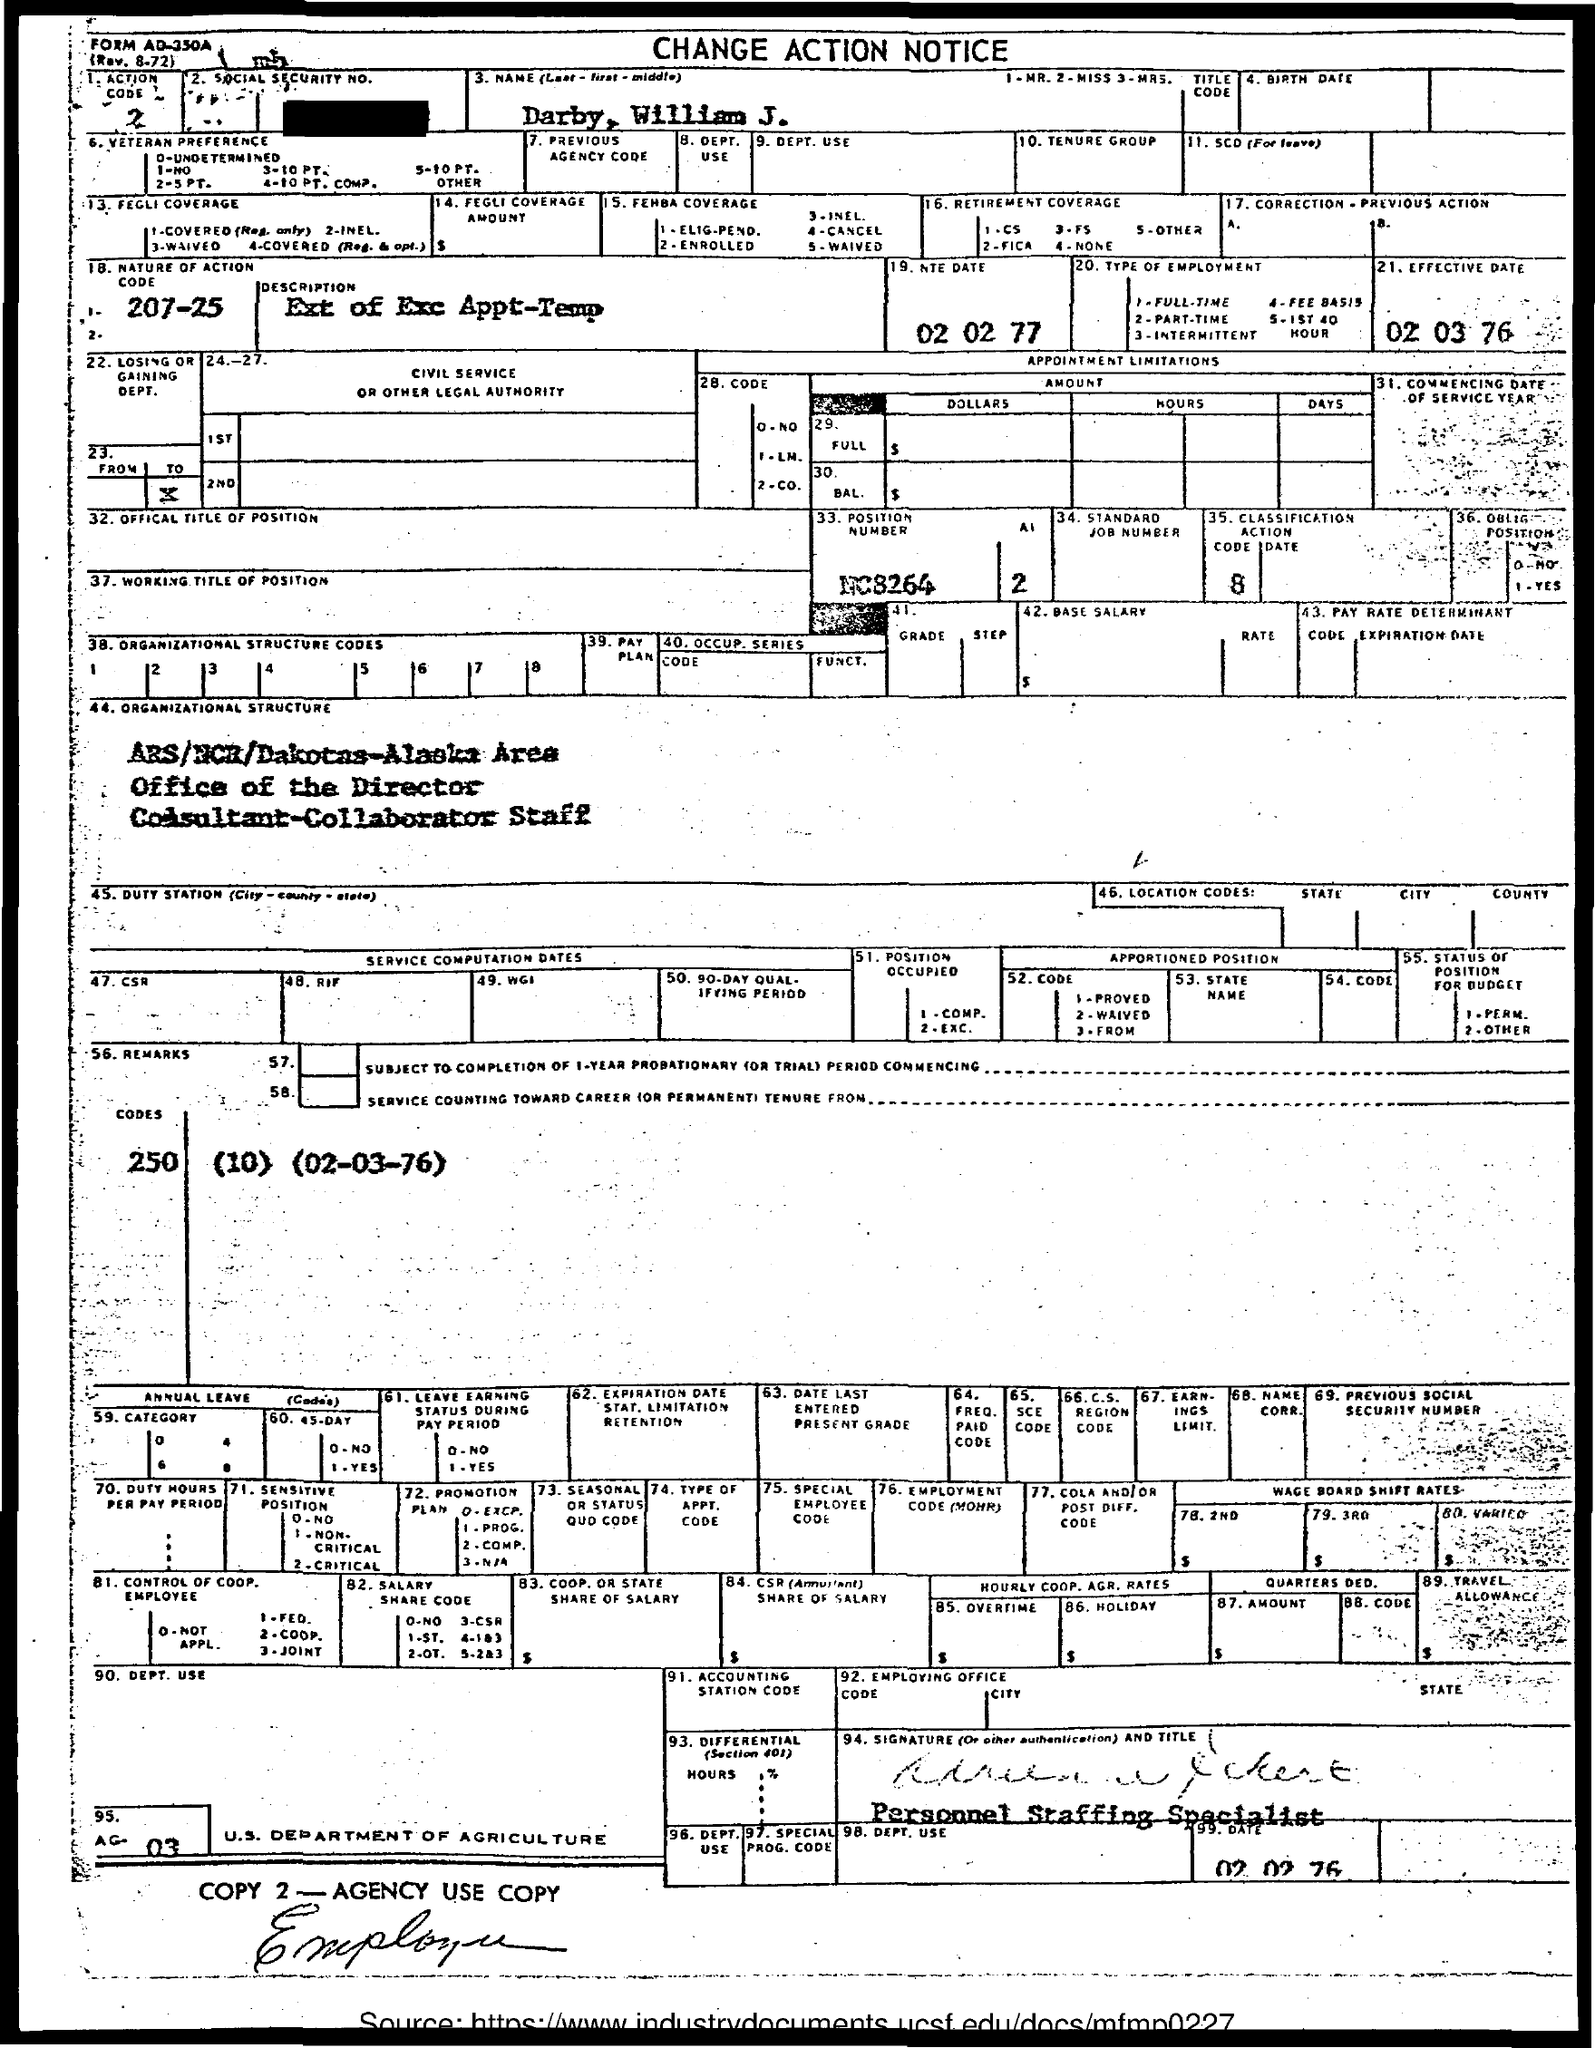What is the nature of action code?
Offer a terse response. 207-25. What is the effective date?
Your answer should be compact. 02 03 76. 